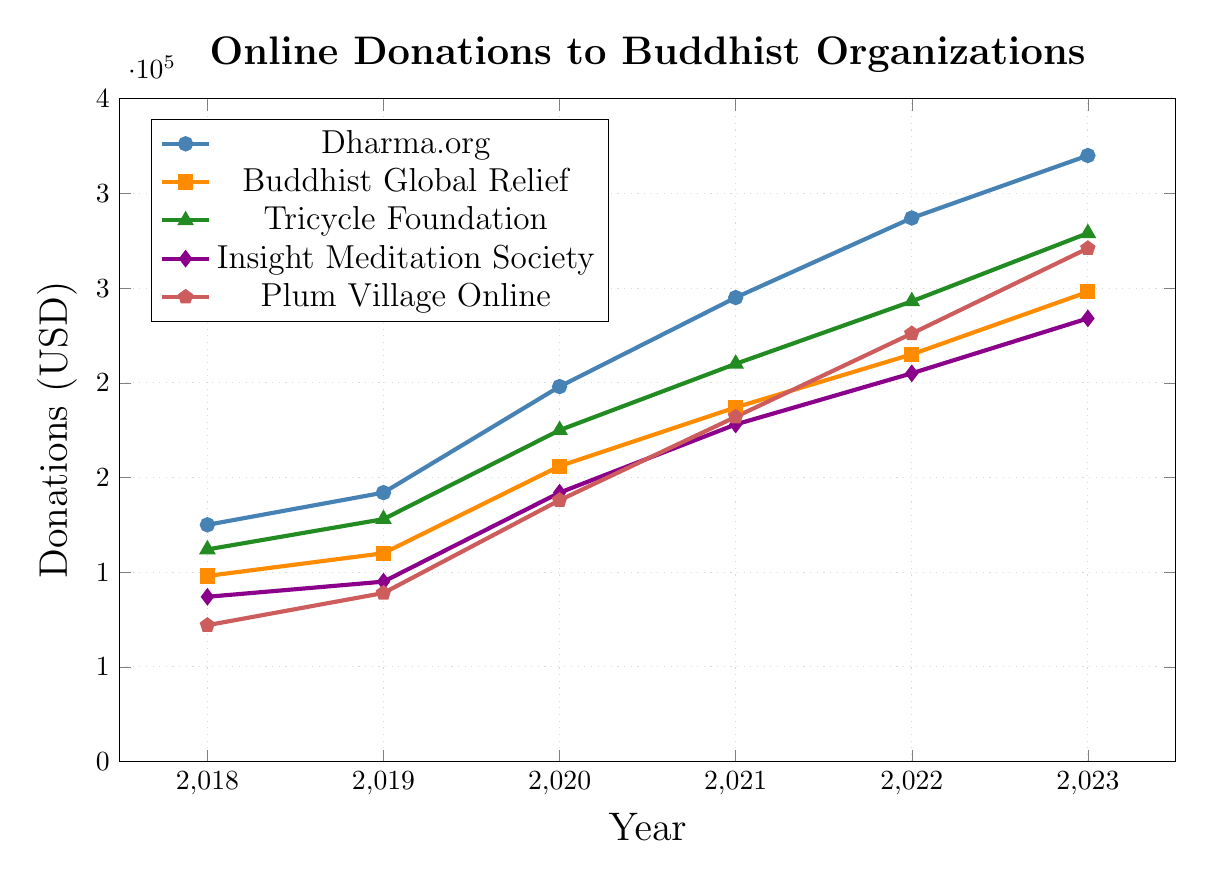What year did Tricycle Foundation experience the highest donations? The Tricycle Foundation experienced the highest donations in 2023, as visualized by the peak on the green triangle-marked line for that year.
Answer: 2023 Which organization had the lowest donations in 2018? In 2018, Plum Village Online had the lowest donations, indicated by the lowest position on the red pentagon-marked line on the y-axis.
Answer: Plum Village Online What's the percentage increase in donations for Insight Meditation Society from 2018 to 2023? First, find the donations in 2018 and 2023 for Insight Meditation Society, which are 87,000 USD and 234,000 USD respectively. The percentage increase is calculated as ((234,000 - 87,000) / 87,000) * 100 = approximately 169%.
Answer: 169% In which year did Dharma.org see the largest increase in donations compared to the previous year? Comparing year-over-year increases for Dharma.org: 
2018 -> 2019: 142,000 - 125,000 = 17,000
2019 -> 2020: 198,000 - 142,000 = 56,000
2020 -> 2021: 245,000 - 198,000 = 47,000
2021 -> 2022: 287,000 - 245,000 = 42,000
2022 -> 2023: 320,000 - 287,000 = 33,000
The largest increase occurred from 2019 to 2020.
Answer: 2020 Which two organizations had the closest donation amounts in 2023? By visually comparing the markers at the 2023 data point, the organizations with the closest donations are Insight Meditation Society (234,000 USD) and Tricycle Foundation (279,000 USD). The difference is calculated as 279,000 - 234,000 = 45,000. Plum Village Online and Tricycle Foundation have a smaller difference of 279,000 - 271,000 = 8,000 USD.
Answer: Plum Village Online and Tricycle Foundation What is the total amount of donations collected by all organizations in 2022? Sum the donations from each organization in 2022: 287,000 (Dharma.org) + 215,000 (Buddhist Global Relief) + 243,000 (Tricycle Foundation) + 205,000 (Insight Meditation Society) + 226,000 (Plum Village Online) = 1,176,000 USD.
Answer: 1,176,000 USD Compare the growth in donations for Buddhist Global Relief from 2021 to 2023 to that of Plum Village Online over the same period. How do they differ? First, calculate the growth for both:
Buddhist Global Relief from 2021 to 2023: 248,000 - 187,000 = 61,000 
Plum Village Online from 2021 to 2023: 271,000 - 182,000 = 89,000
Plum Village Online had a larger growth in donations.
Answer: Plum Village Online grew by 28,000 more What was the average donation amount for Tricycle Foundation from 2018 to 2023? Sum the donations for Tricycle Foundation from 2018 to 2023: 112,000 + 128,000 + 175,000 + 210,000 + 243,000 + 279,000 = 1,147,000 USD. The average is calculated as 1,147,000 / 6 ≈ 191,167 USD.
Answer: 191,167 USD 